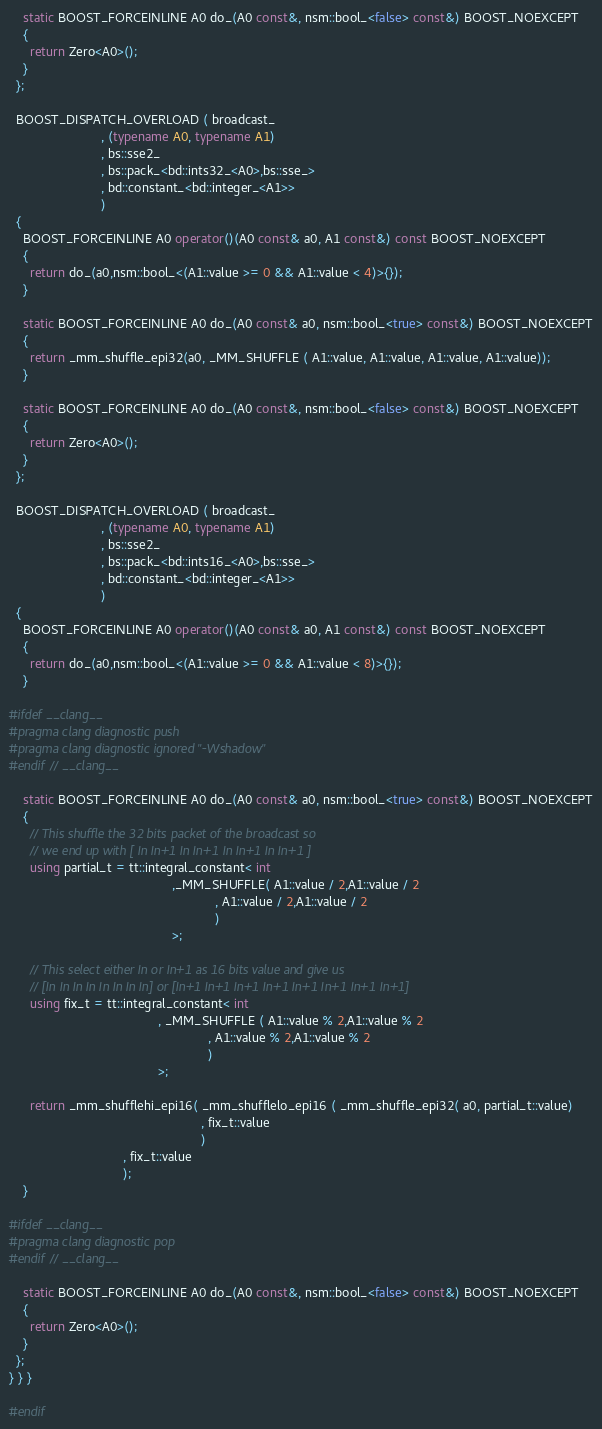<code> <loc_0><loc_0><loc_500><loc_500><_C++_>    static BOOST_FORCEINLINE A0 do_(A0 const&, nsm::bool_<false> const&) BOOST_NOEXCEPT
    {
      return Zero<A0>();
    }
  };

  BOOST_DISPATCH_OVERLOAD ( broadcast_
                          , (typename A0, typename A1)
                          , bs::sse2_
                          , bs::pack_<bd::ints32_<A0>,bs::sse_>
                          , bd::constant_<bd::integer_<A1>>
                          )
  {
    BOOST_FORCEINLINE A0 operator()(A0 const& a0, A1 const&) const BOOST_NOEXCEPT
    {
      return do_(a0,nsm::bool_<(A1::value >= 0 && A1::value < 4)>{});
    }

    static BOOST_FORCEINLINE A0 do_(A0 const& a0, nsm::bool_<true> const&) BOOST_NOEXCEPT
    {
      return _mm_shuffle_epi32(a0, _MM_SHUFFLE ( A1::value, A1::value, A1::value, A1::value));
    }

    static BOOST_FORCEINLINE A0 do_(A0 const&, nsm::bool_<false> const&) BOOST_NOEXCEPT
    {
      return Zero<A0>();
    }
  };

  BOOST_DISPATCH_OVERLOAD ( broadcast_
                          , (typename A0, typename A1)
                          , bs::sse2_
                          , bs::pack_<bd::ints16_<A0>,bs::sse_>
                          , bd::constant_<bd::integer_<A1>>
                          )
  {
    BOOST_FORCEINLINE A0 operator()(A0 const& a0, A1 const&) const BOOST_NOEXCEPT
    {
      return do_(a0,nsm::bool_<(A1::value >= 0 && A1::value < 8)>{});
    }

#ifdef __clang__
#pragma clang diagnostic push
#pragma clang diagnostic ignored "-Wshadow"
#endif // __clang__

    static BOOST_FORCEINLINE A0 do_(A0 const& a0, nsm::bool_<true> const&) BOOST_NOEXCEPT
    {
      // This shuffle the 32 bits packet of the broadcast so
      // we end up with [ In In+1 In In+1 In In+1 In In+1 ]
      using partial_t = tt::integral_constant< int
                                              ,_MM_SHUFFLE( A1::value / 2,A1::value / 2
                                                          , A1::value / 2,A1::value / 2
                                                          )
                                              >;

      // This select either In or In+1 as 16 bits value and give us
      // [In In In In In In In In] or [In+1 In+1 In+1 In+1 In+1 In+1 In+1 In+1]
      using fix_t = tt::integral_constant< int
                                          , _MM_SHUFFLE ( A1::value % 2,A1::value % 2
                                                        , A1::value % 2,A1::value % 2
                                                        )
                                          >;

      return _mm_shufflehi_epi16( _mm_shufflelo_epi16 ( _mm_shuffle_epi32( a0, partial_t::value)
                                                      , fix_t::value
                                                      )
                                , fix_t::value
                                );
    }

#ifdef __clang__
#pragma clang diagnostic pop
#endif // __clang__

    static BOOST_FORCEINLINE A0 do_(A0 const&, nsm::bool_<false> const&) BOOST_NOEXCEPT
    {
      return Zero<A0>();
    }
  };
} } }

#endif
</code> 